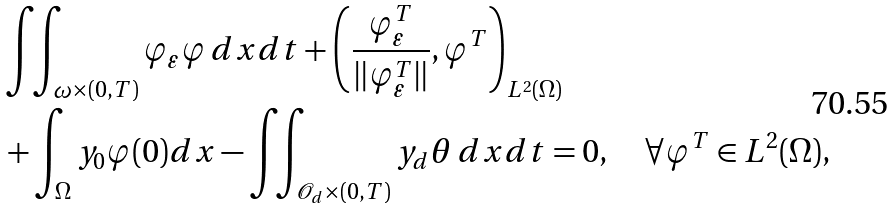<formula> <loc_0><loc_0><loc_500><loc_500>& \iint _ { \omega \times ( 0 , T ) } \varphi _ { \varepsilon } \varphi \, d x d t + \left ( \frac { \varphi _ { \varepsilon } ^ { T } } { \| \varphi _ { \varepsilon } ^ { T } \| } , \varphi ^ { T } \right ) _ { L ^ { 2 } ( \Omega ) } \\ & + \int _ { \Omega } y _ { 0 } \varphi ( 0 ) d x - \iint _ { \mathcal { O } _ { d } \times ( 0 , T ) } y _ { d } \theta \, d x d t = 0 , \quad \forall \varphi ^ { T } \in L ^ { 2 } ( \Omega ) ,</formula> 